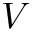<formula> <loc_0><loc_0><loc_500><loc_500>V</formula> 